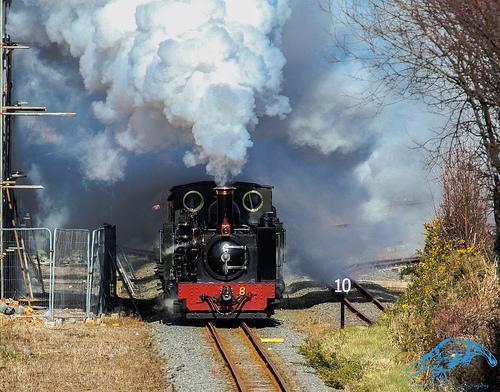How many trains are in the water?
Give a very brief answer. 0. 